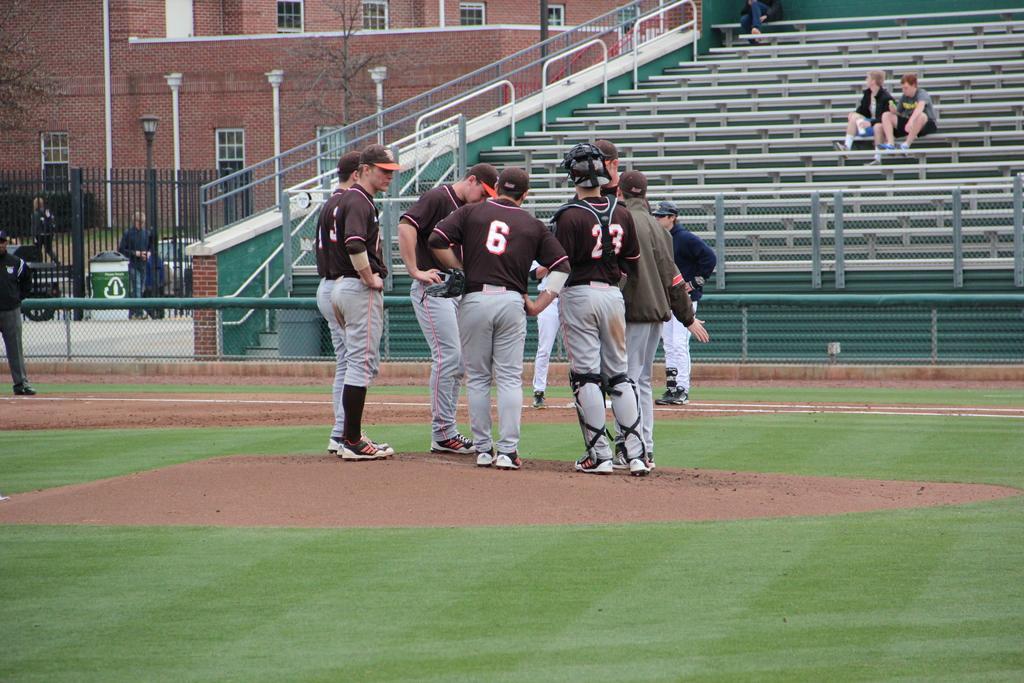Could you give a brief overview of what you see in this image? In this image we can see the players standing on the ground. In the background we can see three people sitting on the benches. We can also see the fence and behind the fence we can see the black color fence, building, trees and also a light pole. 